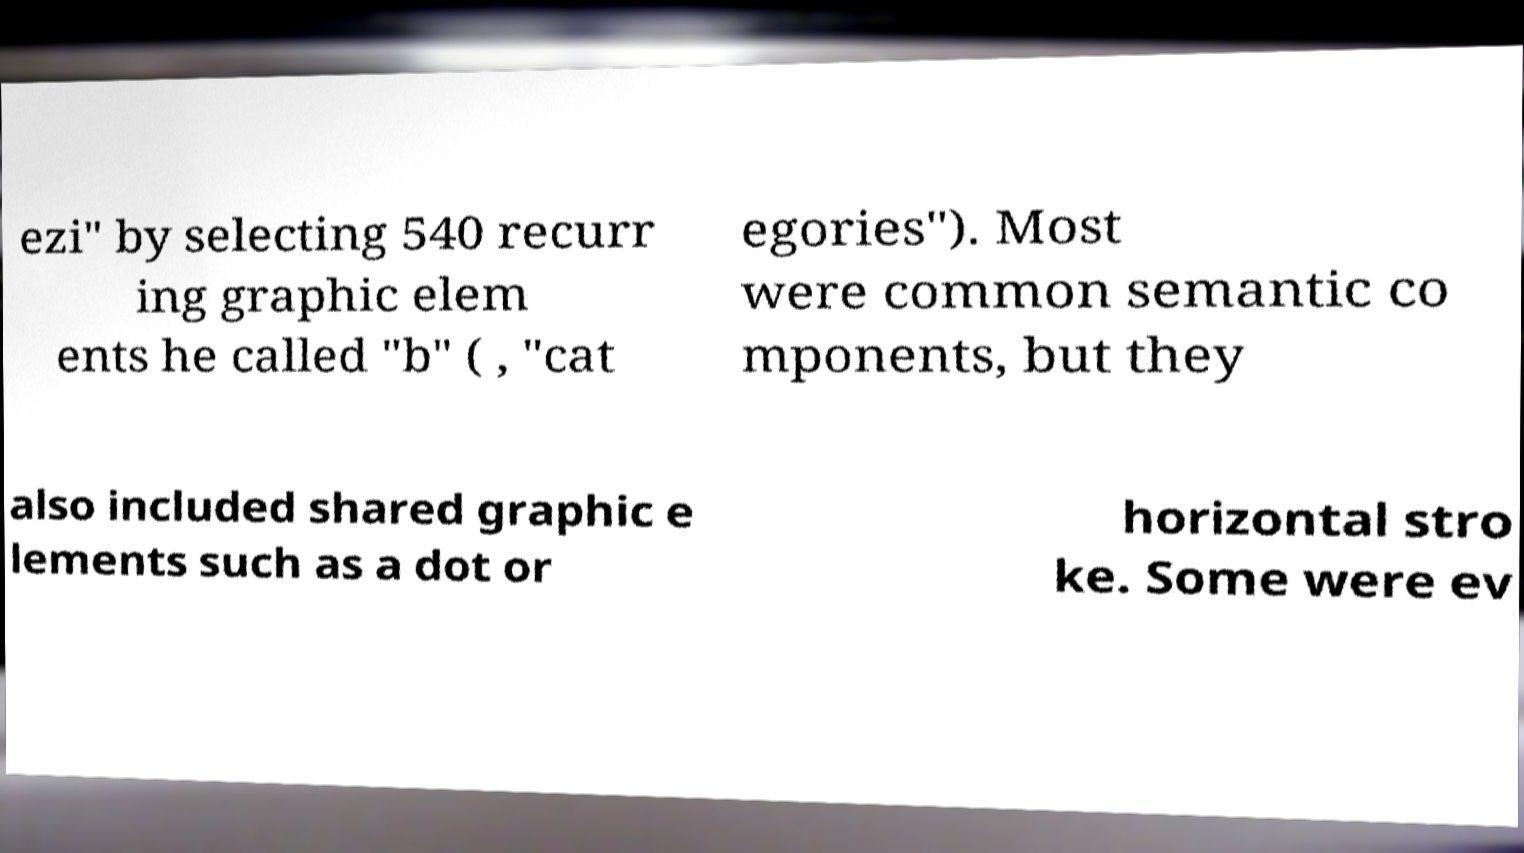Could you extract and type out the text from this image? ezi" by selecting 540 recurr ing graphic elem ents he called "b" ( , "cat egories"). Most were common semantic co mponents, but they also included shared graphic e lements such as a dot or horizontal stro ke. Some were ev 